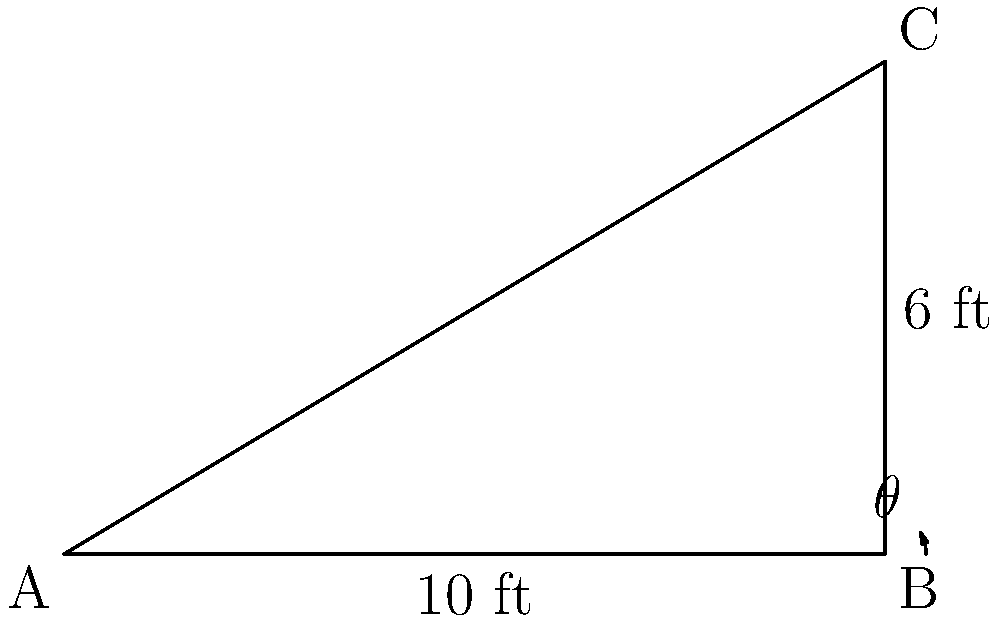A playground slide forms a right-angled triangle with the ground. The base of the slide is 10 feet long, and the height is 6 feet. What is the angle $\theta$ (in degrees) between the slide and the ground? Round your answer to the nearest whole number. To find the angle $\theta$, we can use the inverse tangent function (arctan or $\tan^{-1}$). Here's how:

1) In a right-angled triangle, $\tan(\theta) = \frac{\text{opposite}}{\text{adjacent}}$

2) In this case:
   - The opposite side is the height of the slide = 6 feet
   - The adjacent side is the base of the slide = 10 feet

3) So, we have:
   $\tan(\theta) = \frac{6}{10} = 0.6$

4) To find $\theta$, we take the inverse tangent:
   $\theta = \tan^{-1}(0.6)$

5) Using a calculator:
   $\theta \approx 30.96^\circ$

6) Rounding to the nearest whole number:
   $\theta \approx 31^\circ$

This angle is important for child safety as it determines how fast children will slide down. A steeper angle might be too fast and potentially dangerous.
Answer: $31^\circ$ 